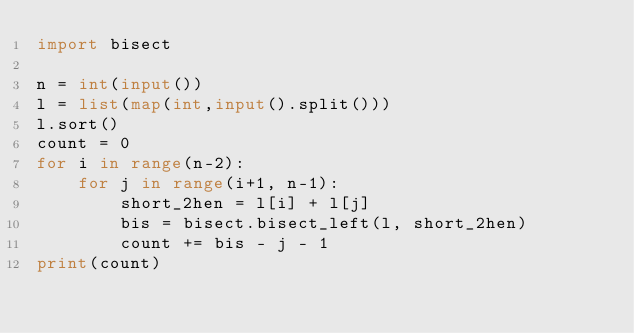Convert code to text. <code><loc_0><loc_0><loc_500><loc_500><_Python_>import bisect

n = int(input())
l = list(map(int,input().split()))
l.sort()
count = 0
for i in range(n-2):
    for j in range(i+1, n-1):
        short_2hen = l[i] + l[j]
        bis = bisect.bisect_left(l, short_2hen)
        count += bis - j - 1
print(count)
</code> 